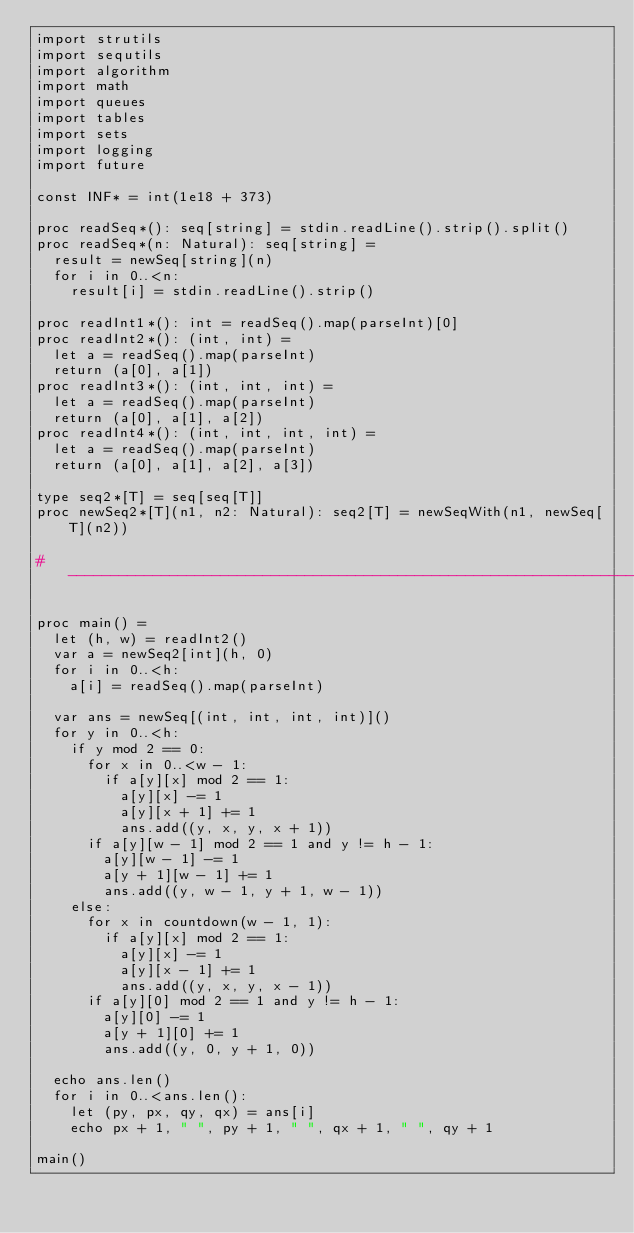<code> <loc_0><loc_0><loc_500><loc_500><_Nim_>import strutils
import sequtils
import algorithm
import math
import queues
import tables
import sets
import logging
import future

const INF* = int(1e18 + 373)

proc readSeq*(): seq[string] = stdin.readLine().strip().split()
proc readSeq*(n: Natural): seq[string] =
  result = newSeq[string](n)
  for i in 0..<n:
    result[i] = stdin.readLine().strip()

proc readInt1*(): int = readSeq().map(parseInt)[0]
proc readInt2*(): (int, int) =
  let a = readSeq().map(parseInt)
  return (a[0], a[1])
proc readInt3*(): (int, int, int) =
  let a = readSeq().map(parseInt)
  return (a[0], a[1], a[2])
proc readInt4*(): (int, int, int, int) =
  let a = readSeq().map(parseInt)
  return (a[0], a[1], a[2], a[3])

type seq2*[T] = seq[seq[T]]
proc newSeq2*[T](n1, n2: Natural): seq2[T] = newSeqWith(n1, newSeq[T](n2))

#------------------------------------------------------------------------------#

proc main() =
  let (h, w) = readInt2()
  var a = newSeq2[int](h, 0)
  for i in 0..<h:
    a[i] = readSeq().map(parseInt)

  var ans = newSeq[(int, int, int, int)]()
  for y in 0..<h:
    if y mod 2 == 0:
      for x in 0..<w - 1:
        if a[y][x] mod 2 == 1:
          a[y][x] -= 1
          a[y][x + 1] += 1
          ans.add((y, x, y, x + 1))
      if a[y][w - 1] mod 2 == 1 and y != h - 1:
        a[y][w - 1] -= 1
        a[y + 1][w - 1] += 1
        ans.add((y, w - 1, y + 1, w - 1))
    else:
      for x in countdown(w - 1, 1):
        if a[y][x] mod 2 == 1:
          a[y][x] -= 1
          a[y][x - 1] += 1
          ans.add((y, x, y, x - 1))
      if a[y][0] mod 2 == 1 and y != h - 1:
        a[y][0] -= 1
        a[y + 1][0] += 1
        ans.add((y, 0, y + 1, 0))

  echo ans.len()
  for i in 0..<ans.len():
    let (py, px, qy, qx) = ans[i]
    echo px + 1, " ", py + 1, " ", qx + 1, " ", qy + 1

main()

</code> 